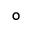<formula> <loc_0><loc_0><loc_500><loc_500>^ { \circ }</formula> 